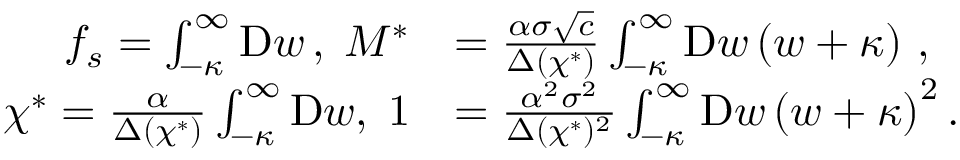Convert formula to latex. <formula><loc_0><loc_0><loc_500><loc_500>\begin{array} { r l } { f _ { s } = \int _ { - \kappa } ^ { \infty } D w \, , \, M ^ { * } } & { = \frac { \alpha \sigma \sqrt { c } } { \Delta ( \chi ^ { * } ) } \int _ { - \kappa } ^ { \infty } D w \left ( w + \kappa \right ) \, , } \\ { \chi ^ { * } = \frac { \alpha } { \Delta ( \chi ^ { * } ) } \int _ { - \kappa } ^ { \infty } D w , \, 1 } & { = \frac { \alpha ^ { 2 } \sigma ^ { 2 } } { \Delta ( \chi ^ { * } ) ^ { 2 } } \int _ { - \kappa } ^ { \infty } D w \left ( w + \kappa \right ) ^ { 2 } . } \end{array}</formula> 